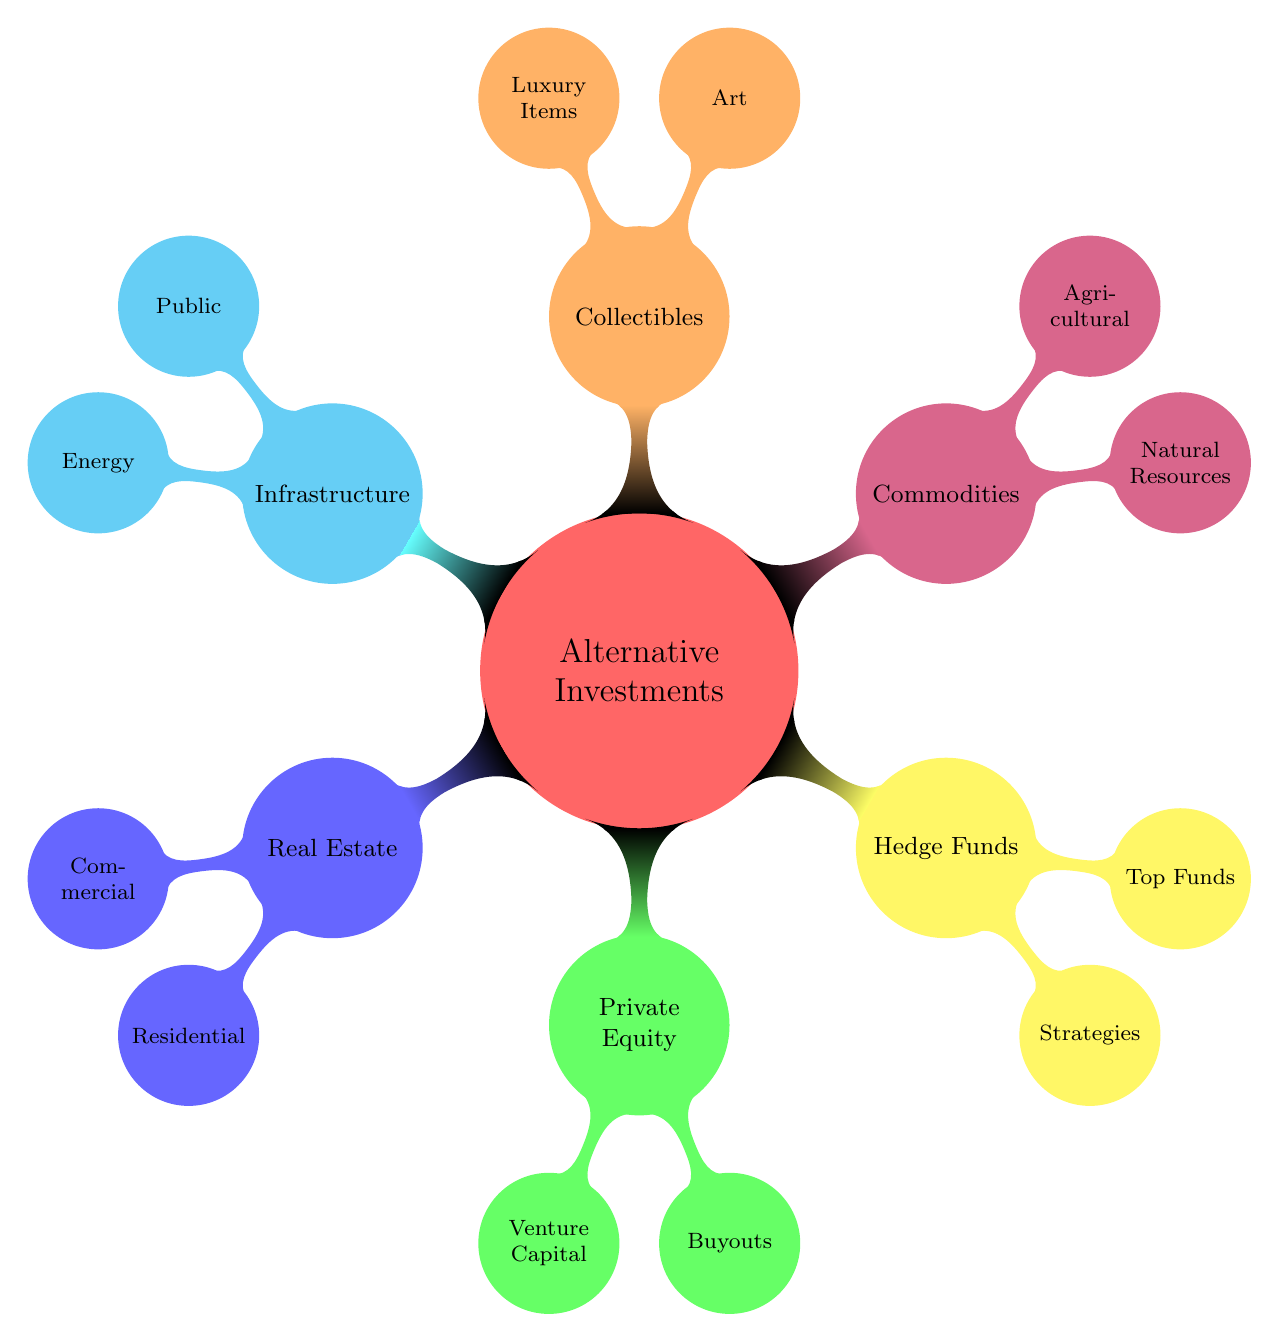What are the two main categories under Real Estate? The diagram shows under Real Estate, there are two main categories: Commercial Properties and Residential Properties.
Answer: Commercial Properties, Residential Properties How many primary sections are there in Alternative Investments? The diagram clearly displays that there are six primary sections branching out from Alternative Investments: Real Estate, Private Equity, Hedge Funds, Commodities, Collectibles, and Infrastructure.
Answer: Six What type of funding is classified under Venture Capital? The diagram specifies that under Venture Capital, there are two types: Seed Funding and Series A Funding. Both of these types fall under the Venture Capital category in Private Equity.
Answer: Seed Funding, Series A Funding Which category contains Art as a sub-category? In the diagram, Art is noted as a sub-category under Collectibles. This means that when looking at Collectibles, Art has been specified as one of its types.
Answer: Collectibles What is a strategy listed under Hedge Funds? The diagram outlines that under Hedge Funds, a strategy is Long/Short Equity, which is one of the different strategies employed in this investment category.
Answer: Long/Short Equity How many types of properties are listed under Commercial Properties? The diagram indicates that there are three types of properties under Commercial Properties: Offices, Shopping Malls, and Warehouses, which are the specific examples provided.
Answer: Three Which alternative investment category includes Oil? According to the diagram, Oil is included under the Commodities category, specifically under Natural Resources, which classifies various natural commodities.
Answer: Commodities What are two examples of Luxury Items in Collectibles? The diagram shows that under the Collectibles category, two examples of Luxury Items are Watches and Classic Cars. These items exemplify what falls under the Luxury Items sub-category.
Answer: Watches, Classic Cars Name one type of Energy Infrastructure. The diagram presents that one type of Energy Infrastructure is Power Plants. It specifically identifies this sub-category under the broader Infrastructure section.
Answer: Power Plants 